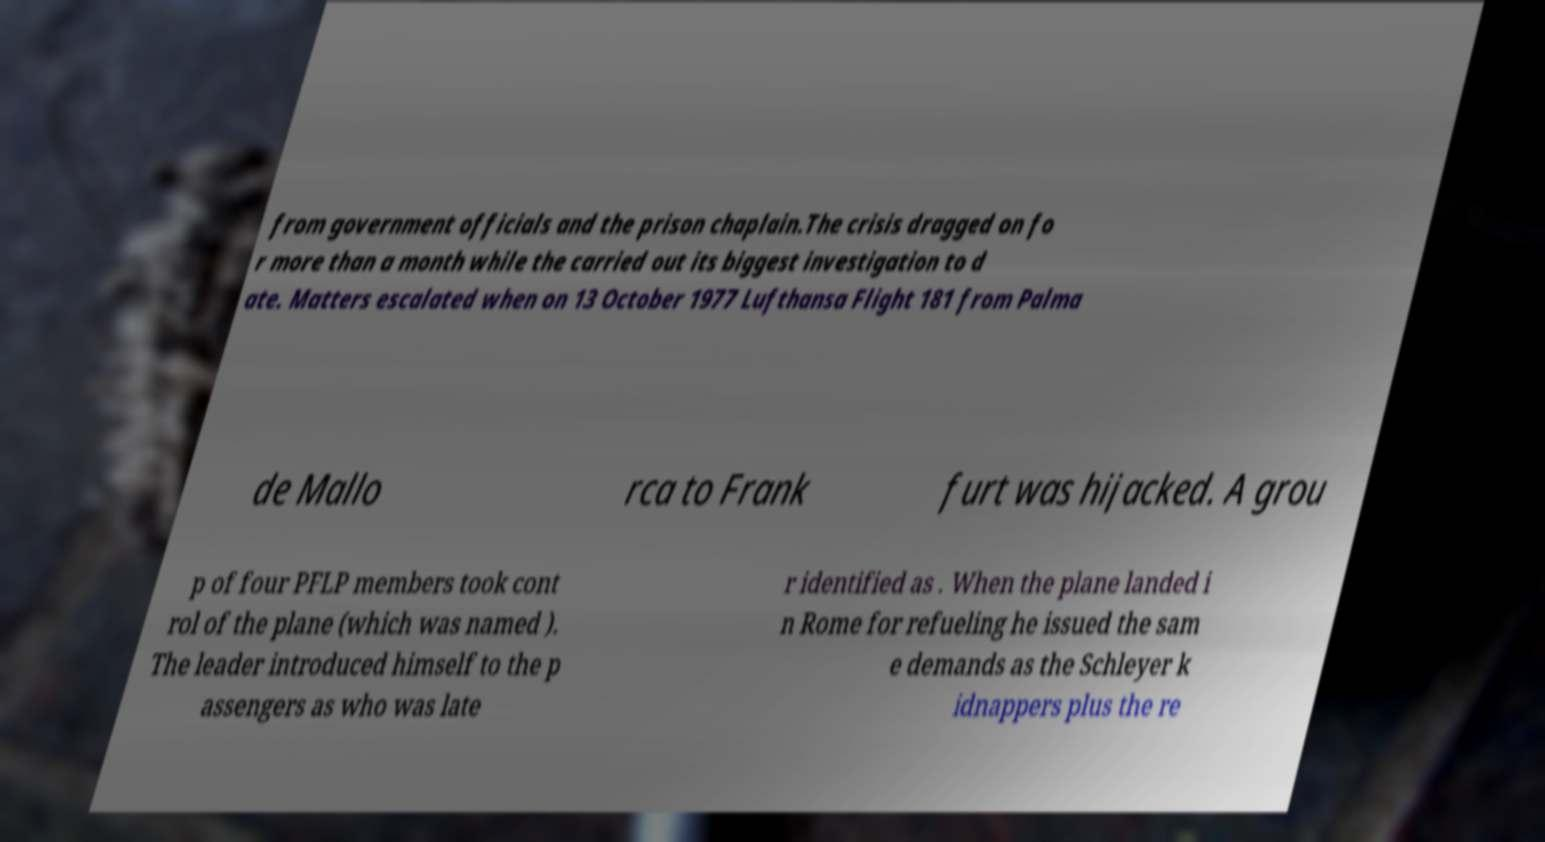What messages or text are displayed in this image? I need them in a readable, typed format. from government officials and the prison chaplain.The crisis dragged on fo r more than a month while the carried out its biggest investigation to d ate. Matters escalated when on 13 October 1977 Lufthansa Flight 181 from Palma de Mallo rca to Frank furt was hijacked. A grou p of four PFLP members took cont rol of the plane (which was named ). The leader introduced himself to the p assengers as who was late r identified as . When the plane landed i n Rome for refueling he issued the sam e demands as the Schleyer k idnappers plus the re 